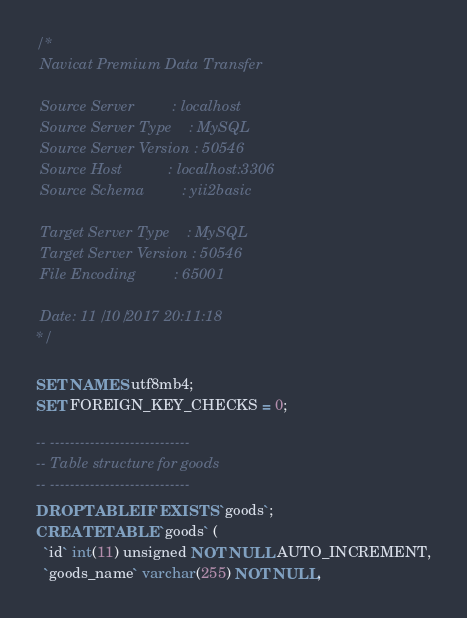<code> <loc_0><loc_0><loc_500><loc_500><_SQL_>/*
 Navicat Premium Data Transfer

 Source Server         : localhost
 Source Server Type    : MySQL
 Source Server Version : 50546
 Source Host           : localhost:3306
 Source Schema         : yii2basic

 Target Server Type    : MySQL
 Target Server Version : 50546
 File Encoding         : 65001

 Date: 11/10/2017 20:11:18
*/

SET NAMES utf8mb4;
SET FOREIGN_KEY_CHECKS = 0;

-- ----------------------------
-- Table structure for goods
-- ----------------------------
DROP TABLE IF EXISTS `goods`;
CREATE TABLE `goods` (
  `id` int(11) unsigned NOT NULL AUTO_INCREMENT,
  `goods_name` varchar(255) NOT NULL,</code> 